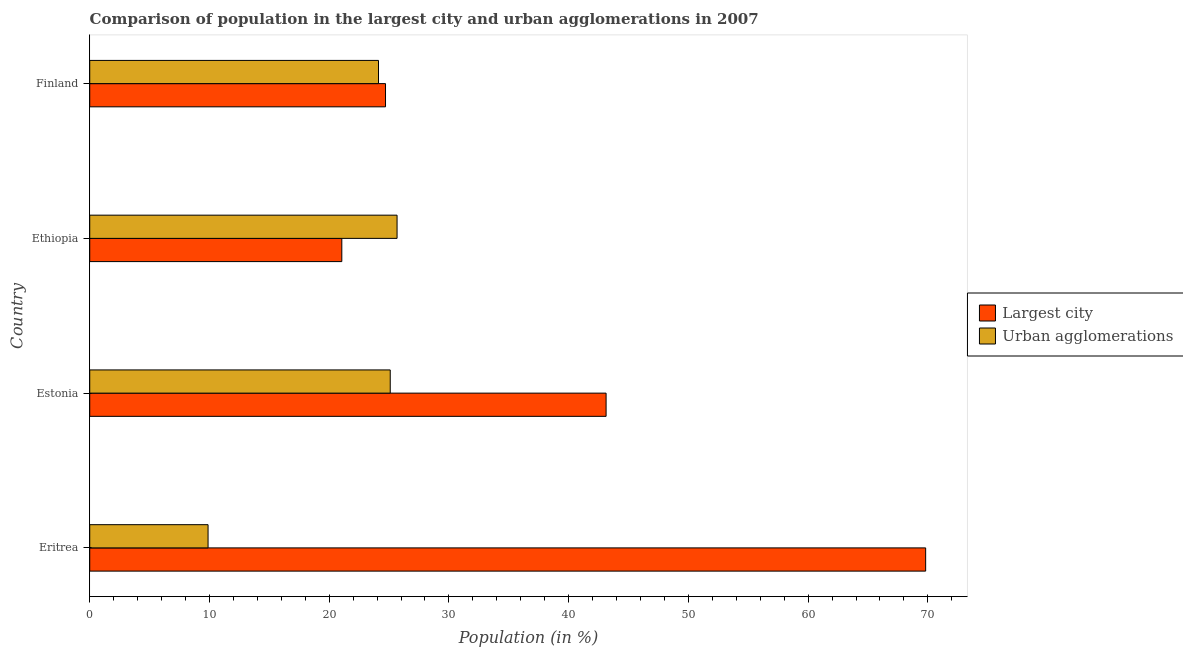How many different coloured bars are there?
Give a very brief answer. 2. How many groups of bars are there?
Your answer should be very brief. 4. Are the number of bars per tick equal to the number of legend labels?
Your response must be concise. Yes. How many bars are there on the 2nd tick from the top?
Keep it short and to the point. 2. How many bars are there on the 2nd tick from the bottom?
Your response must be concise. 2. What is the label of the 4th group of bars from the top?
Give a very brief answer. Eritrea. In how many cases, is the number of bars for a given country not equal to the number of legend labels?
Provide a short and direct response. 0. What is the population in urban agglomerations in Eritrea?
Ensure brevity in your answer.  9.88. Across all countries, what is the maximum population in the largest city?
Ensure brevity in your answer.  69.82. Across all countries, what is the minimum population in urban agglomerations?
Keep it short and to the point. 9.88. In which country was the population in the largest city maximum?
Your answer should be very brief. Eritrea. In which country was the population in the largest city minimum?
Offer a very short reply. Ethiopia. What is the total population in urban agglomerations in the graph?
Your response must be concise. 84.77. What is the difference between the population in urban agglomerations in Estonia and that in Ethiopia?
Your answer should be very brief. -0.57. What is the difference between the population in urban agglomerations in Estonia and the population in the largest city in Finland?
Provide a succinct answer. 0.39. What is the average population in urban agglomerations per country?
Your answer should be very brief. 21.19. What is the difference between the population in urban agglomerations and population in the largest city in Ethiopia?
Offer a very short reply. 4.62. In how many countries, is the population in the largest city greater than 14 %?
Give a very brief answer. 4. What is the ratio of the population in urban agglomerations in Eritrea to that in Finland?
Your answer should be compact. 0.41. Is the population in urban agglomerations in Estonia less than that in Finland?
Keep it short and to the point. No. What is the difference between the highest and the second highest population in urban agglomerations?
Your answer should be very brief. 0.57. What is the difference between the highest and the lowest population in the largest city?
Provide a short and direct response. 48.76. Is the sum of the population in urban agglomerations in Ethiopia and Finland greater than the maximum population in the largest city across all countries?
Your response must be concise. No. What does the 1st bar from the top in Estonia represents?
Your response must be concise. Urban agglomerations. What does the 1st bar from the bottom in Finland represents?
Make the answer very short. Largest city. How many bars are there?
Make the answer very short. 8. How many countries are there in the graph?
Your answer should be very brief. 4. What is the difference between two consecutive major ticks on the X-axis?
Make the answer very short. 10. Are the values on the major ticks of X-axis written in scientific E-notation?
Make the answer very short. No. Does the graph contain grids?
Ensure brevity in your answer.  No. Where does the legend appear in the graph?
Provide a succinct answer. Center right. How are the legend labels stacked?
Give a very brief answer. Vertical. What is the title of the graph?
Your response must be concise. Comparison of population in the largest city and urban agglomerations in 2007. Does "Non-solid fuel" appear as one of the legend labels in the graph?
Provide a short and direct response. No. What is the label or title of the Y-axis?
Offer a very short reply. Country. What is the Population (in %) in Largest city in Eritrea?
Make the answer very short. 69.82. What is the Population (in %) in Urban agglomerations in Eritrea?
Your response must be concise. 9.88. What is the Population (in %) of Largest city in Estonia?
Give a very brief answer. 43.13. What is the Population (in %) of Urban agglomerations in Estonia?
Your response must be concise. 25.1. What is the Population (in %) in Largest city in Ethiopia?
Your response must be concise. 21.05. What is the Population (in %) in Urban agglomerations in Ethiopia?
Provide a succinct answer. 25.67. What is the Population (in %) of Largest city in Finland?
Offer a very short reply. 24.71. What is the Population (in %) of Urban agglomerations in Finland?
Make the answer very short. 24.12. Across all countries, what is the maximum Population (in %) of Largest city?
Keep it short and to the point. 69.82. Across all countries, what is the maximum Population (in %) of Urban agglomerations?
Offer a very short reply. 25.67. Across all countries, what is the minimum Population (in %) in Largest city?
Your answer should be very brief. 21.05. Across all countries, what is the minimum Population (in %) of Urban agglomerations?
Provide a short and direct response. 9.88. What is the total Population (in %) of Largest city in the graph?
Ensure brevity in your answer.  158.71. What is the total Population (in %) in Urban agglomerations in the graph?
Provide a short and direct response. 84.77. What is the difference between the Population (in %) in Largest city in Eritrea and that in Estonia?
Your answer should be very brief. 26.69. What is the difference between the Population (in %) of Urban agglomerations in Eritrea and that in Estonia?
Give a very brief answer. -15.21. What is the difference between the Population (in %) in Largest city in Eritrea and that in Ethiopia?
Make the answer very short. 48.76. What is the difference between the Population (in %) of Urban agglomerations in Eritrea and that in Ethiopia?
Your answer should be compact. -15.79. What is the difference between the Population (in %) of Largest city in Eritrea and that in Finland?
Offer a terse response. 45.11. What is the difference between the Population (in %) in Urban agglomerations in Eritrea and that in Finland?
Offer a terse response. -14.23. What is the difference between the Population (in %) of Largest city in Estonia and that in Ethiopia?
Your response must be concise. 22.07. What is the difference between the Population (in %) of Urban agglomerations in Estonia and that in Ethiopia?
Offer a very short reply. -0.57. What is the difference between the Population (in %) of Largest city in Estonia and that in Finland?
Ensure brevity in your answer.  18.42. What is the difference between the Population (in %) of Urban agglomerations in Estonia and that in Finland?
Your response must be concise. 0.98. What is the difference between the Population (in %) of Largest city in Ethiopia and that in Finland?
Make the answer very short. -3.65. What is the difference between the Population (in %) of Urban agglomerations in Ethiopia and that in Finland?
Provide a succinct answer. 1.55. What is the difference between the Population (in %) in Largest city in Eritrea and the Population (in %) in Urban agglomerations in Estonia?
Provide a succinct answer. 44.72. What is the difference between the Population (in %) of Largest city in Eritrea and the Population (in %) of Urban agglomerations in Ethiopia?
Give a very brief answer. 44.15. What is the difference between the Population (in %) of Largest city in Eritrea and the Population (in %) of Urban agglomerations in Finland?
Ensure brevity in your answer.  45.7. What is the difference between the Population (in %) in Largest city in Estonia and the Population (in %) in Urban agglomerations in Ethiopia?
Offer a very short reply. 17.46. What is the difference between the Population (in %) of Largest city in Estonia and the Population (in %) of Urban agglomerations in Finland?
Give a very brief answer. 19.01. What is the difference between the Population (in %) in Largest city in Ethiopia and the Population (in %) in Urban agglomerations in Finland?
Offer a terse response. -3.06. What is the average Population (in %) of Largest city per country?
Your answer should be very brief. 39.68. What is the average Population (in %) in Urban agglomerations per country?
Keep it short and to the point. 21.19. What is the difference between the Population (in %) in Largest city and Population (in %) in Urban agglomerations in Eritrea?
Your answer should be very brief. 59.93. What is the difference between the Population (in %) of Largest city and Population (in %) of Urban agglomerations in Estonia?
Provide a short and direct response. 18.03. What is the difference between the Population (in %) of Largest city and Population (in %) of Urban agglomerations in Ethiopia?
Provide a short and direct response. -4.61. What is the difference between the Population (in %) in Largest city and Population (in %) in Urban agglomerations in Finland?
Keep it short and to the point. 0.59. What is the ratio of the Population (in %) in Largest city in Eritrea to that in Estonia?
Keep it short and to the point. 1.62. What is the ratio of the Population (in %) of Urban agglomerations in Eritrea to that in Estonia?
Make the answer very short. 0.39. What is the ratio of the Population (in %) of Largest city in Eritrea to that in Ethiopia?
Your answer should be very brief. 3.32. What is the ratio of the Population (in %) of Urban agglomerations in Eritrea to that in Ethiopia?
Your answer should be very brief. 0.39. What is the ratio of the Population (in %) of Largest city in Eritrea to that in Finland?
Your answer should be compact. 2.83. What is the ratio of the Population (in %) of Urban agglomerations in Eritrea to that in Finland?
Provide a succinct answer. 0.41. What is the ratio of the Population (in %) of Largest city in Estonia to that in Ethiopia?
Your response must be concise. 2.05. What is the ratio of the Population (in %) in Urban agglomerations in Estonia to that in Ethiopia?
Keep it short and to the point. 0.98. What is the ratio of the Population (in %) in Largest city in Estonia to that in Finland?
Offer a very short reply. 1.75. What is the ratio of the Population (in %) in Urban agglomerations in Estonia to that in Finland?
Provide a short and direct response. 1.04. What is the ratio of the Population (in %) of Largest city in Ethiopia to that in Finland?
Provide a succinct answer. 0.85. What is the ratio of the Population (in %) in Urban agglomerations in Ethiopia to that in Finland?
Offer a terse response. 1.06. What is the difference between the highest and the second highest Population (in %) in Largest city?
Your response must be concise. 26.69. What is the difference between the highest and the second highest Population (in %) in Urban agglomerations?
Give a very brief answer. 0.57. What is the difference between the highest and the lowest Population (in %) of Largest city?
Offer a very short reply. 48.76. What is the difference between the highest and the lowest Population (in %) of Urban agglomerations?
Offer a very short reply. 15.79. 